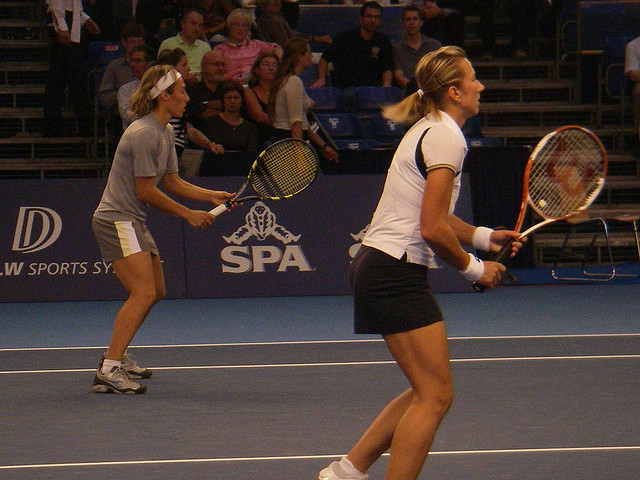How many people are visible? In the image, there are only two players visible on the tennis court, both in mid-action, suggesting a doubles match. 